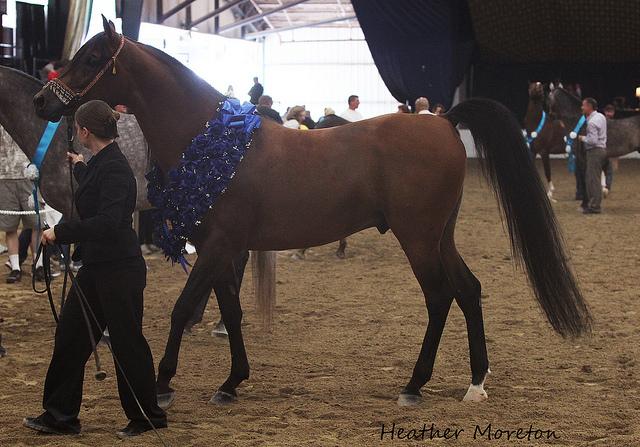What is standing beside the horse?
Give a very brief answer. Woman. Does this animal give milk?
Give a very brief answer. No. What is the man doing?
Concise answer only. Walking horse. Can the horse use its periphery vision?
Quick response, please. Yes. How many horses do you see?
Quick response, please. 4. Is the woman wearing a hat?
Write a very short answer. No. Is this horse ready to be ridden?
Concise answer only. No. Is the horse walking on grass?
Keep it brief. No. How many saddles do you see?
Give a very brief answer. 0. What is the sex of this animal?
Write a very short answer. Male. How many spots are on the horse with the blue harness?
Concise answer only. 0. What color is this horse?
Quick response, please. Brown. What color is the horse's ribbon?
Short answer required. Blue. Is this a current photo?
Keep it brief. Yes. What are these people riding?
Be succinct. Horses. Will the second horse enter the trailer?
Quick response, please. No. Does this horse have matching hooves?
Short answer required. No. Is the horse wearing a saddle?
Keep it brief. No. What animals are shown?
Quick response, please. Horse. 